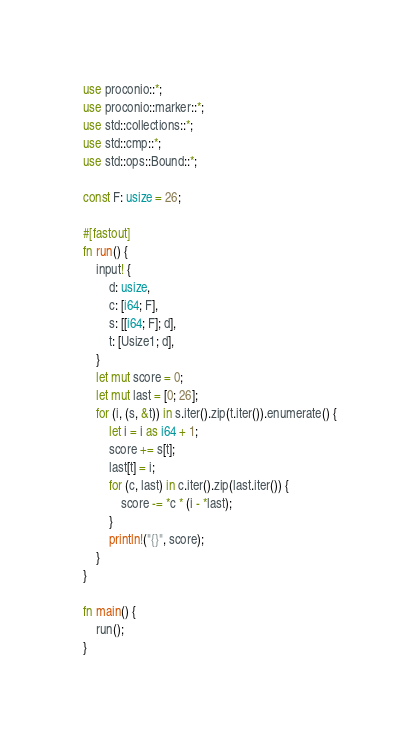Convert code to text. <code><loc_0><loc_0><loc_500><loc_500><_Rust_>use proconio::*;
use proconio::marker::*;
use std::collections::*;
use std::cmp::*;
use std::ops::Bound::*;

const F: usize = 26;

#[fastout]
fn run() {
    input! {
        d: usize,
        c: [i64; F],
        s: [[i64; F]; d],
        t: [Usize1; d],
    }
    let mut score = 0;
    let mut last = [0; 26];
    for (i, (s, &t)) in s.iter().zip(t.iter()).enumerate() {
        let i = i as i64 + 1;
        score += s[t];
        last[t] = i;
        for (c, last) in c.iter().zip(last.iter()) {
            score -= *c * (i - *last);
        }
        println!("{}", score);
    }
}

fn main() {
    run();
}
</code> 